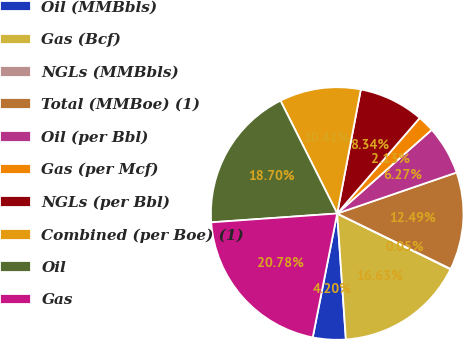Convert chart. <chart><loc_0><loc_0><loc_500><loc_500><pie_chart><fcel>Oil (MMBbls)<fcel>Gas (Bcf)<fcel>NGLs (MMBbls)<fcel>Total (MMBoe) (1)<fcel>Oil (per Bbl)<fcel>Gas (per Mcf)<fcel>NGLs (per Bbl)<fcel>Combined (per Boe) (1)<fcel>Oil<fcel>Gas<nl><fcel>4.2%<fcel>16.63%<fcel>0.05%<fcel>12.49%<fcel>6.27%<fcel>2.13%<fcel>8.34%<fcel>10.41%<fcel>18.7%<fcel>20.78%<nl></chart> 